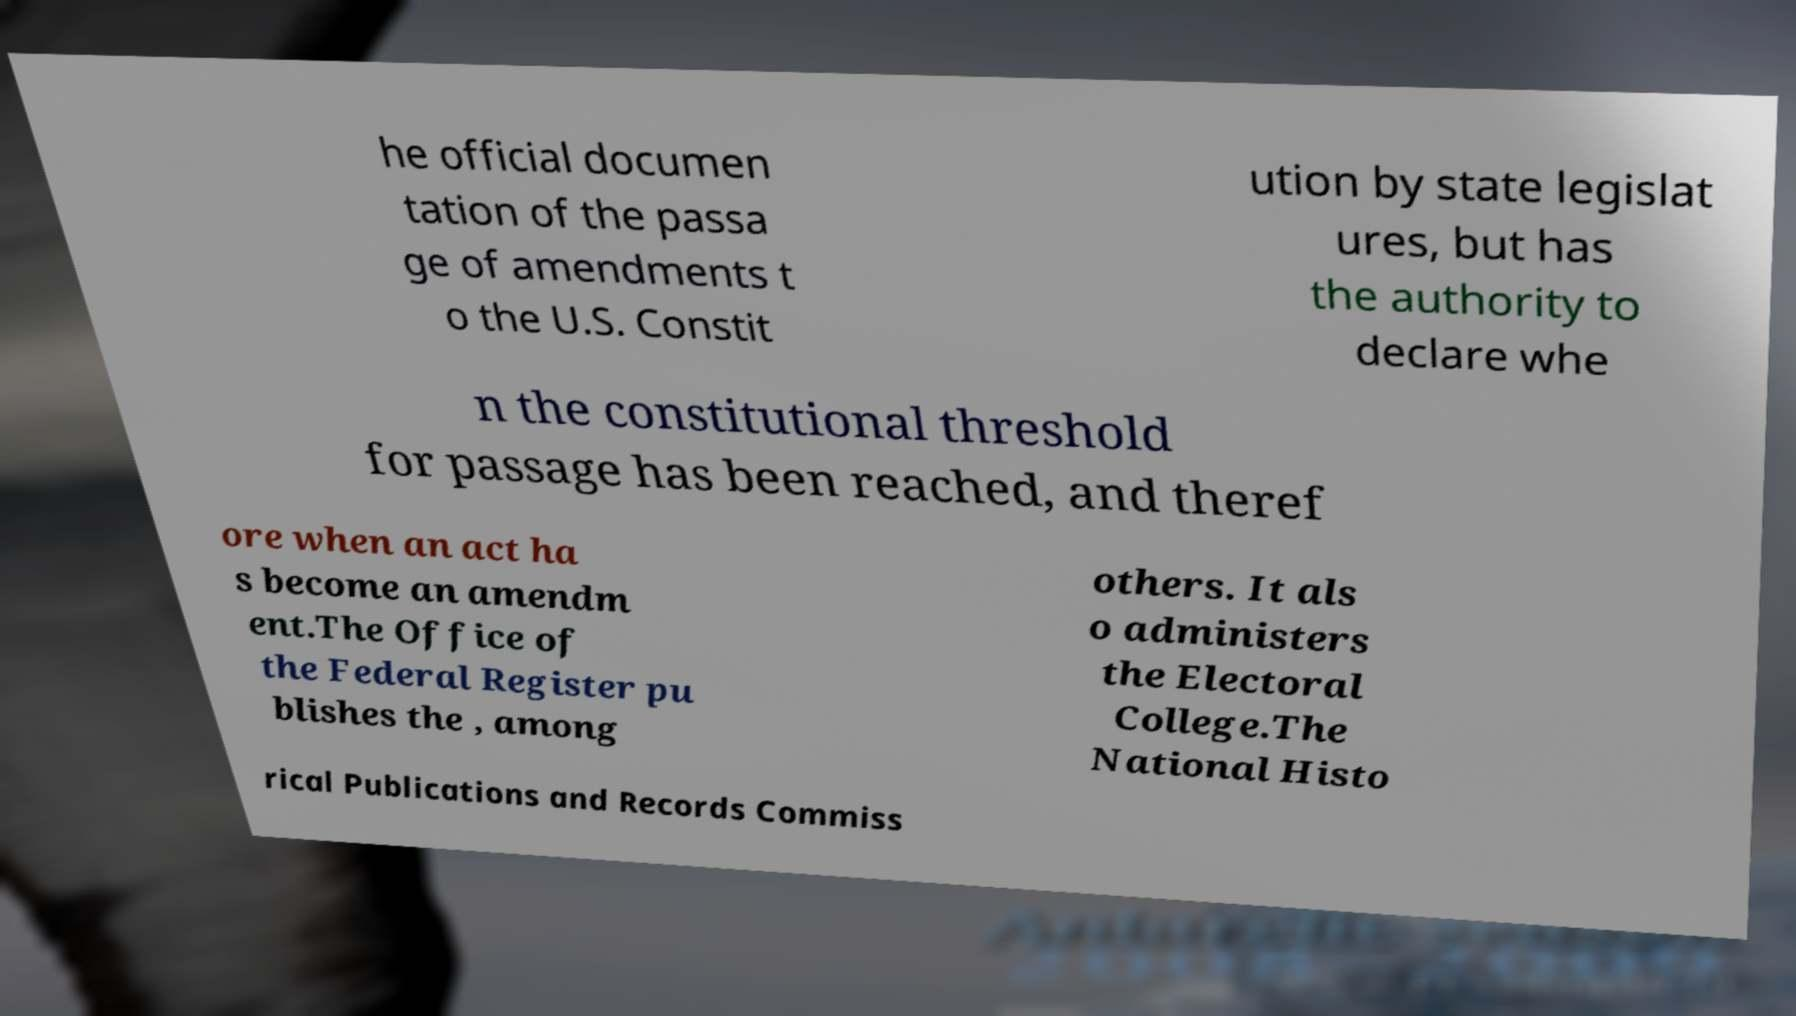Please read and relay the text visible in this image. What does it say? he official documen tation of the passa ge of amendments t o the U.S. Constit ution by state legislat ures, but has the authority to declare whe n the constitutional threshold for passage has been reached, and theref ore when an act ha s become an amendm ent.The Office of the Federal Register pu blishes the , among others. It als o administers the Electoral College.The National Histo rical Publications and Records Commiss 